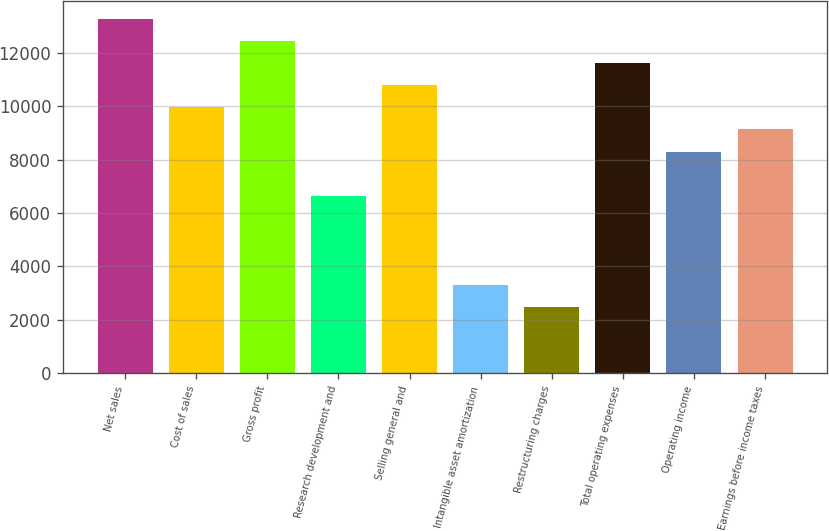Convert chart. <chart><loc_0><loc_0><loc_500><loc_500><bar_chart><fcel>Net sales<fcel>Cost of sales<fcel>Gross profit<fcel>Research development and<fcel>Selling general and<fcel>Intangible asset amortization<fcel>Restructuring charges<fcel>Total operating expenses<fcel>Operating income<fcel>Earnings before income taxes<nl><fcel>13289.4<fcel>9967.8<fcel>12459<fcel>6646.2<fcel>10798.2<fcel>3324.6<fcel>2494.2<fcel>11628.6<fcel>8307<fcel>9137.4<nl></chart> 